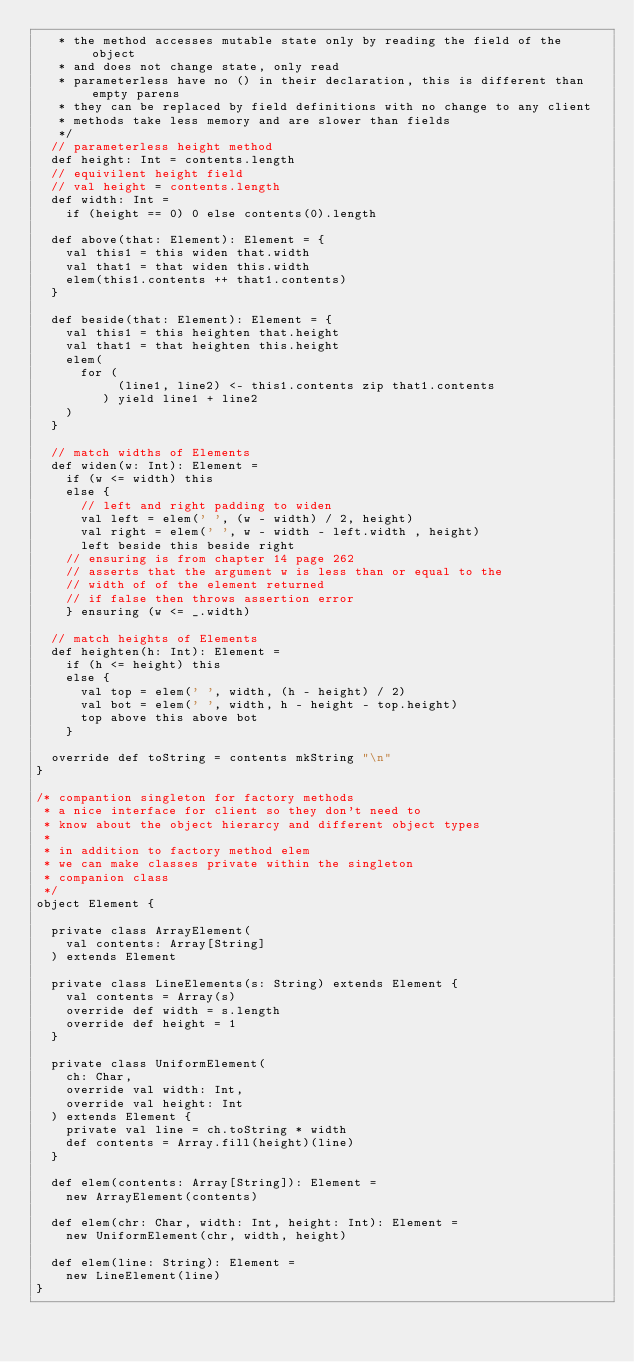Convert code to text. <code><loc_0><loc_0><loc_500><loc_500><_Scala_>   * the method accesses mutable state only by reading the field of the object
   * and does not change state, only read
   * parameterless have no () in their declaration, this is different than empty parens
   * they can be replaced by field definitions with no change to any client
   * methods take less memory and are slower than fields
   */
  // parameterless height method
  def height: Int = contents.length
  // equivilent height field
  // val height = contents.length
  def width: Int =
    if (height == 0) 0 else contents(0).length

  def above(that: Element): Element = {
    val this1 = this widen that.width
    val that1 = that widen this.width
    elem(this1.contents ++ that1.contents)
  }

  def beside(that: Element): Element = {
    val this1 = this heighten that.height
    val that1 = that heighten this.height
    elem(
      for (
           (line1, line2) <- this1.contents zip that1.contents
         ) yield line1 + line2
    )
  }

  // match widths of Elements
  def widen(w: Int): Element =
    if (w <= width) this
    else {
      // left and right padding to widen
      val left = elem(' ', (w - width) / 2, height)
      val right = elem(' ', w - width - left.width , height)
      left beside this beside right
    // ensuring is from chapter 14 page 262
    // asserts that the argument w is less than or equal to the
    // width of of the element returned
    // if false then throws assertion error
    } ensuring (w <= _.width)

  // match heights of Elements
  def heighten(h: Int): Element =
    if (h <= height) this
    else {
      val top = elem(' ', width, (h - height) / 2)
      val bot = elem(' ', width, h - height - top.height)
      top above this above bot
    }

  override def toString = contents mkString "\n"
}

/* compantion singleton for factory methods
 * a nice interface for client so they don't need to
 * know about the object hierarcy and different object types
 *
 * in addition to factory method elem
 * we can make classes private within the singleton
 * companion class
 */
object Element {

  private class ArrayElement(
    val contents: Array[String]
  ) extends Element

  private class LineElements(s: String) extends Element {
    val contents = Array(s)
    override def width = s.length
    override def height = 1
  }

  private class UniformElement(
    ch: Char,
    override val width: Int,
    override val height: Int
  ) extends Element {
    private val line = ch.toString * width
    def contents = Array.fill(height)(line)
  }

  def elem(contents: Array[String]): Element =
    new ArrayElement(contents)

  def elem(chr: Char, width: Int, height: Int): Element =
    new UniformElement(chr, width, height)

  def elem(line: String): Element =
    new LineElement(line)
}
</code> 